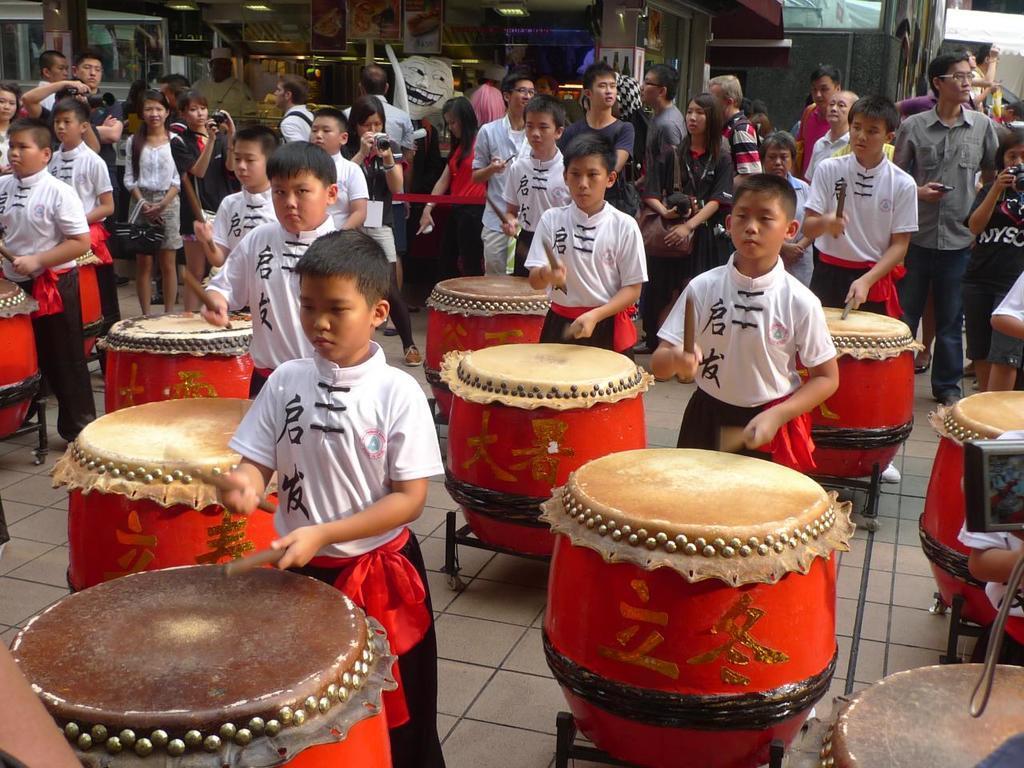Could you give a brief overview of what you see in this image? On the background we can see boards of food items. Here we can see all the boys standing on the floor and playing drums by holding sticks in their hands. Beside to these boys we can see all the persons standing. 